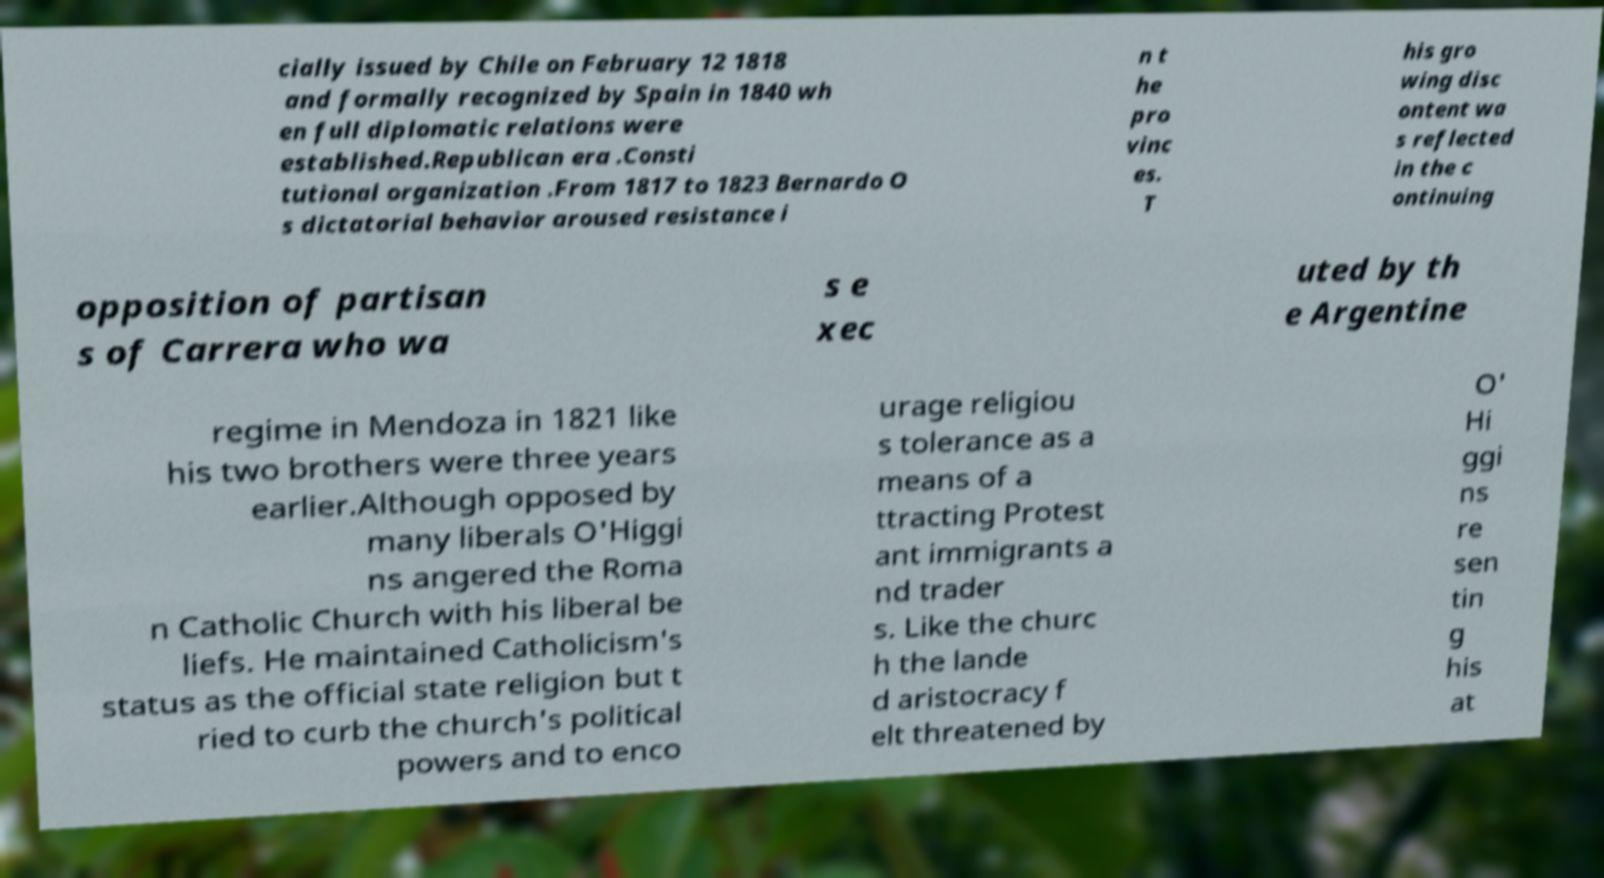What messages or text are displayed in this image? I need them in a readable, typed format. cially issued by Chile on February 12 1818 and formally recognized by Spain in 1840 wh en full diplomatic relations were established.Republican era .Consti tutional organization .From 1817 to 1823 Bernardo O s dictatorial behavior aroused resistance i n t he pro vinc es. T his gro wing disc ontent wa s reflected in the c ontinuing opposition of partisan s of Carrera who wa s e xec uted by th e Argentine regime in Mendoza in 1821 like his two brothers were three years earlier.Although opposed by many liberals O'Higgi ns angered the Roma n Catholic Church with his liberal be liefs. He maintained Catholicism's status as the official state religion but t ried to curb the church's political powers and to enco urage religiou s tolerance as a means of a ttracting Protest ant immigrants a nd trader s. Like the churc h the lande d aristocracy f elt threatened by O' Hi ggi ns re sen tin g his at 